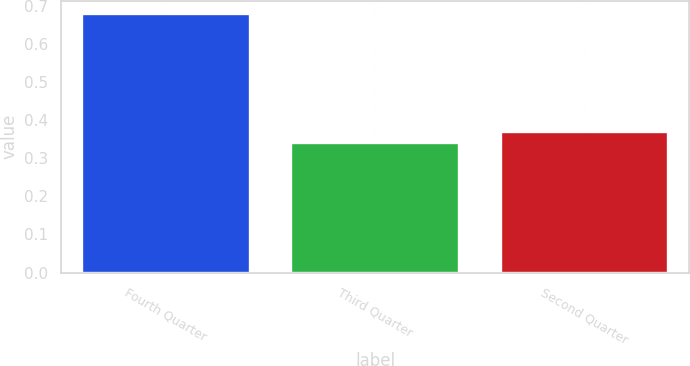Convert chart. <chart><loc_0><loc_0><loc_500><loc_500><bar_chart><fcel>Fourth Quarter<fcel>Third Quarter<fcel>Second Quarter<nl><fcel>0.68<fcel>0.34<fcel>0.37<nl></chart> 